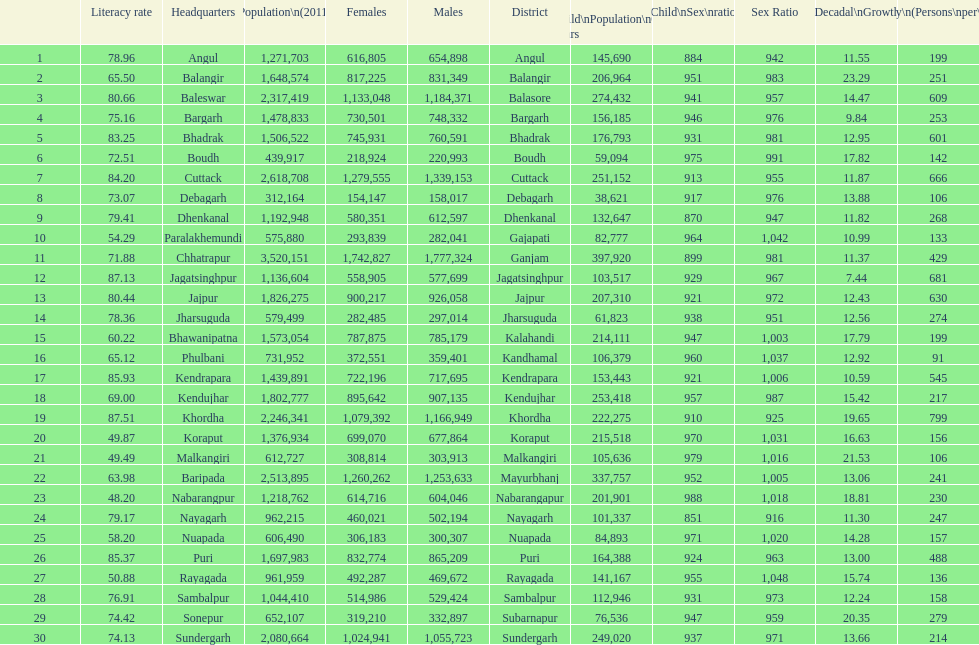Tell me a district that did not have a population over 600,000. Boudh. 